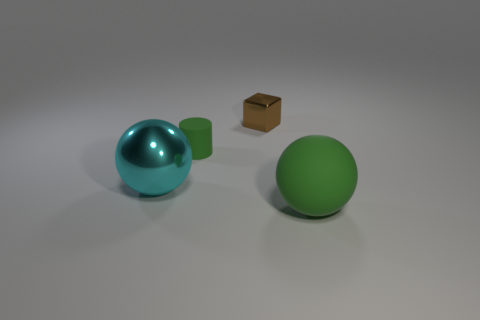What color is the big thing on the right side of the metallic block?
Give a very brief answer. Green. The sphere that is behind the sphere in front of the big ball that is left of the big green rubber thing is made of what material?
Provide a succinct answer. Metal. Is there a green rubber thing that has the same shape as the large shiny object?
Your answer should be very brief. Yes. What shape is the green rubber object that is the same size as the brown cube?
Ensure brevity in your answer.  Cylinder. What number of things are behind the cyan object and in front of the cyan thing?
Provide a short and direct response. 0. Is the number of large cyan metallic balls behind the block less than the number of big yellow spheres?
Provide a short and direct response. No. Are there any metallic things that have the same size as the cylinder?
Provide a short and direct response. Yes. What is the color of the cylinder that is made of the same material as the big green ball?
Your response must be concise. Green. There is a tiny brown cube that is to the left of the big matte sphere; what number of brown metallic cubes are behind it?
Give a very brief answer. 0. What is the material of the object that is on the right side of the green cylinder and behind the big shiny object?
Offer a very short reply. Metal. 